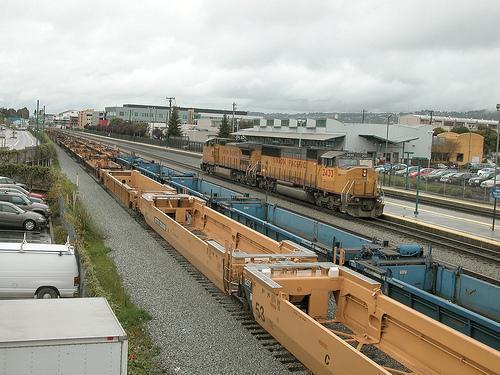How many trains are there?
Give a very brief answer. 1. How many train engines are on the track?
Give a very brief answer. 2. How many cars are shown in the parking lot near the white van?
Give a very brief answer. 5. 